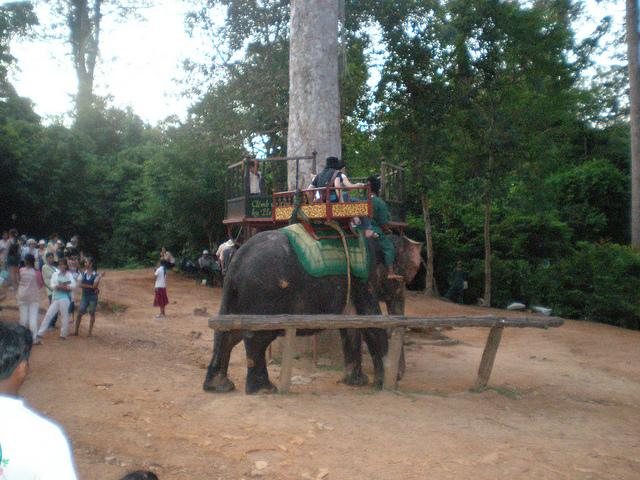What continent is this most likely?

Choices:
A) europe
B) asia
C) antarctica
D) south america asia 